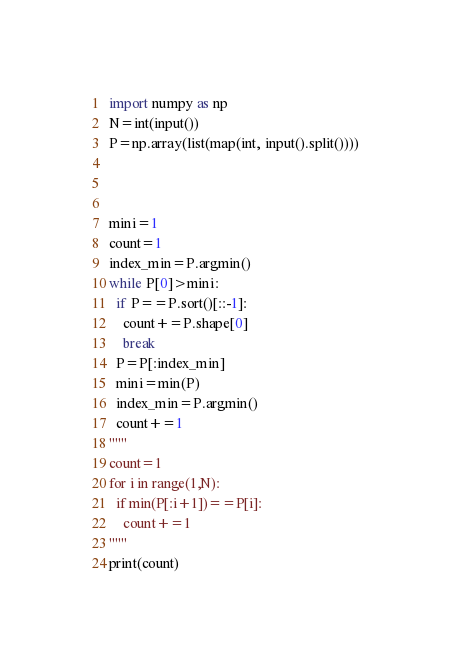Convert code to text. <code><loc_0><loc_0><loc_500><loc_500><_Python_>import numpy as np
N=int(input())
P=np.array(list(map(int, input().split())))



mini=1
count=1
index_min=P.argmin()
while P[0]>mini:
  if P==P.sort()[::-1]:
    count+=P.shape[0]
    break
  P=P[:index_min]
  mini=min(P)
  index_min=P.argmin()
  count+=1
"""
count=1
for i in range(1,N):
  if min(P[:i+1])==P[i]:
    count+=1
"""
print(count)

</code> 